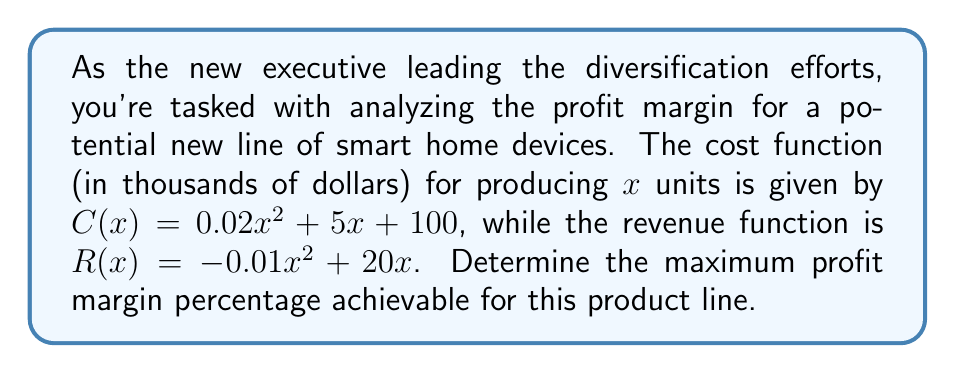Help me with this question. To solve this problem, we'll follow these steps:

1) First, let's define the profit function P(x):
   $$P(x) = R(x) - C(x)$$
   $$P(x) = (-0.01x^2 + 20x) - (0.02x^2 + 5x + 100)$$
   $$P(x) = -0.03x^2 + 15x - 100$$

2) To find the maximum profit, we need to find the vertex of this quadratic function. We can do this by setting the derivative of P(x) to zero:
   $$P'(x) = -0.06x + 15$$
   $$0 = -0.06x + 15$$
   $$0.06x = 15$$
   $$x = 250$$

3) The maximum profit occurs when x = 250. Let's calculate the profit at this point:
   $$P(250) = -0.03(250)^2 + 15(250) - 100$$
   $$P(250) = -1875 + 3750 - 100 = 1775$$

4) Now, let's calculate the revenue at x = 250:
   $$R(250) = -0.01(250)^2 + 20(250) = 3750$$

5) The profit margin percentage is calculated as (Profit / Revenue) * 100:
   $$\text{Profit Margin} = \frac{1775}{3750} * 100 \approx 47.33\%$$

Therefore, the maximum profit margin percentage achievable for this product line is approximately 47.33%.
Answer: 47.33% 